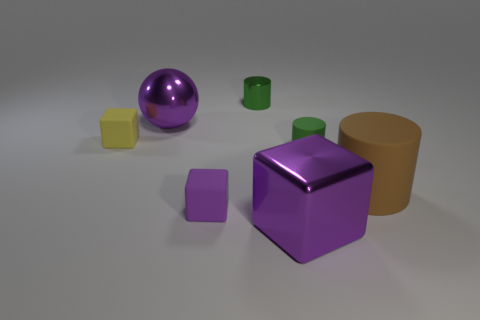Subtract 1 cylinders. How many cylinders are left? 2 Add 1 green matte cylinders. How many objects exist? 8 Subtract all purple objects. Subtract all small yellow objects. How many objects are left? 3 Add 6 brown rubber cylinders. How many brown rubber cylinders are left? 7 Add 7 big cyan matte cylinders. How many big cyan matte cylinders exist? 7 Subtract 0 yellow cylinders. How many objects are left? 7 Subtract all balls. How many objects are left? 6 